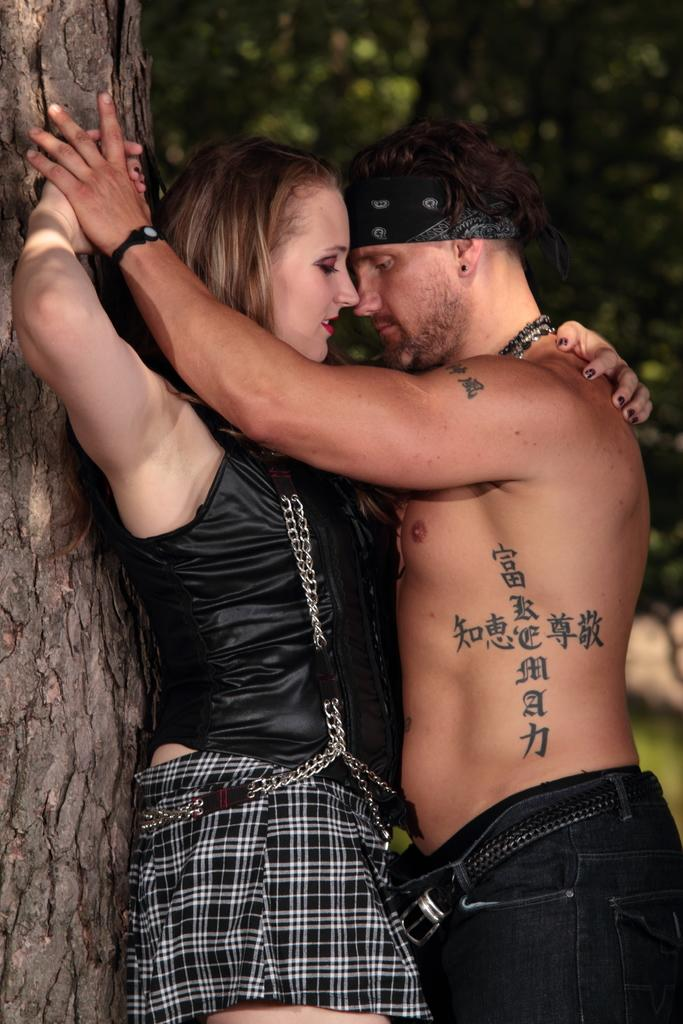Who is present in the image? There is a couple in the image. What are the couple doing in the image? The couple is doing romantic activities. Where are the couple located in the image? They are beside a tree trunk. What can be seen in the background of the image? There are many trees visible in the background of the image. What type of paper and pencil can be seen in the image? There is no paper or pencil present in the image. 